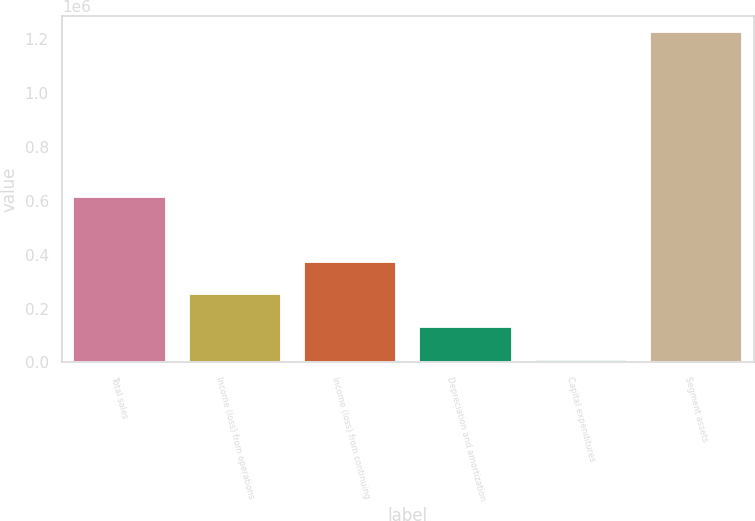<chart> <loc_0><loc_0><loc_500><loc_500><bar_chart><fcel>Total sales<fcel>Income (loss) from operations<fcel>Income (loss) from continuing<fcel>Depreciation and amortization<fcel>Capital expenditures<fcel>Segment assets<nl><fcel>614439<fcel>252588<fcel>374283<fcel>130894<fcel>9199<fcel>1.22614e+06<nl></chart> 